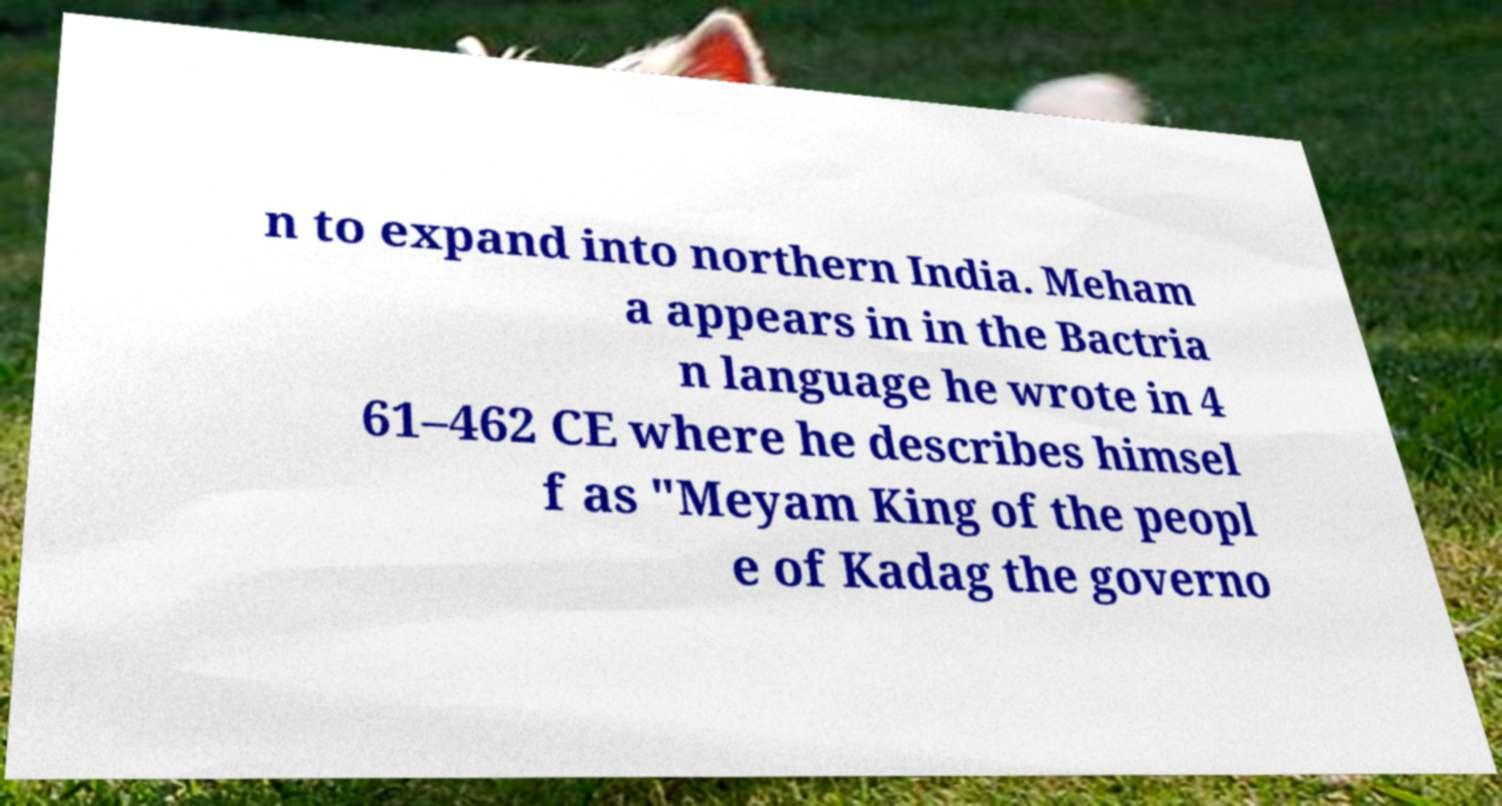Please identify and transcribe the text found in this image. n to expand into northern India. Meham a appears in in the Bactria n language he wrote in 4 61–462 CE where he describes himsel f as "Meyam King of the peopl e of Kadag the governo 